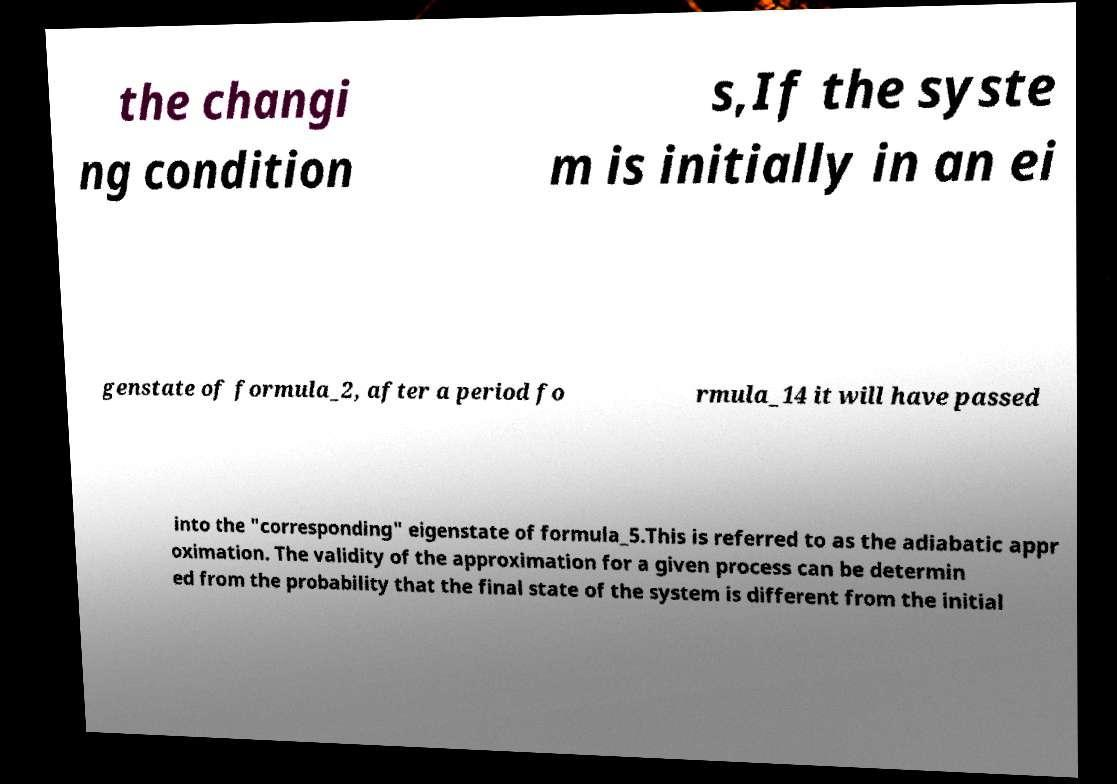Could you extract and type out the text from this image? the changi ng condition s,If the syste m is initially in an ei genstate of formula_2, after a period fo rmula_14 it will have passed into the "corresponding" eigenstate of formula_5.This is referred to as the adiabatic appr oximation. The validity of the approximation for a given process can be determin ed from the probability that the final state of the system is different from the initial 